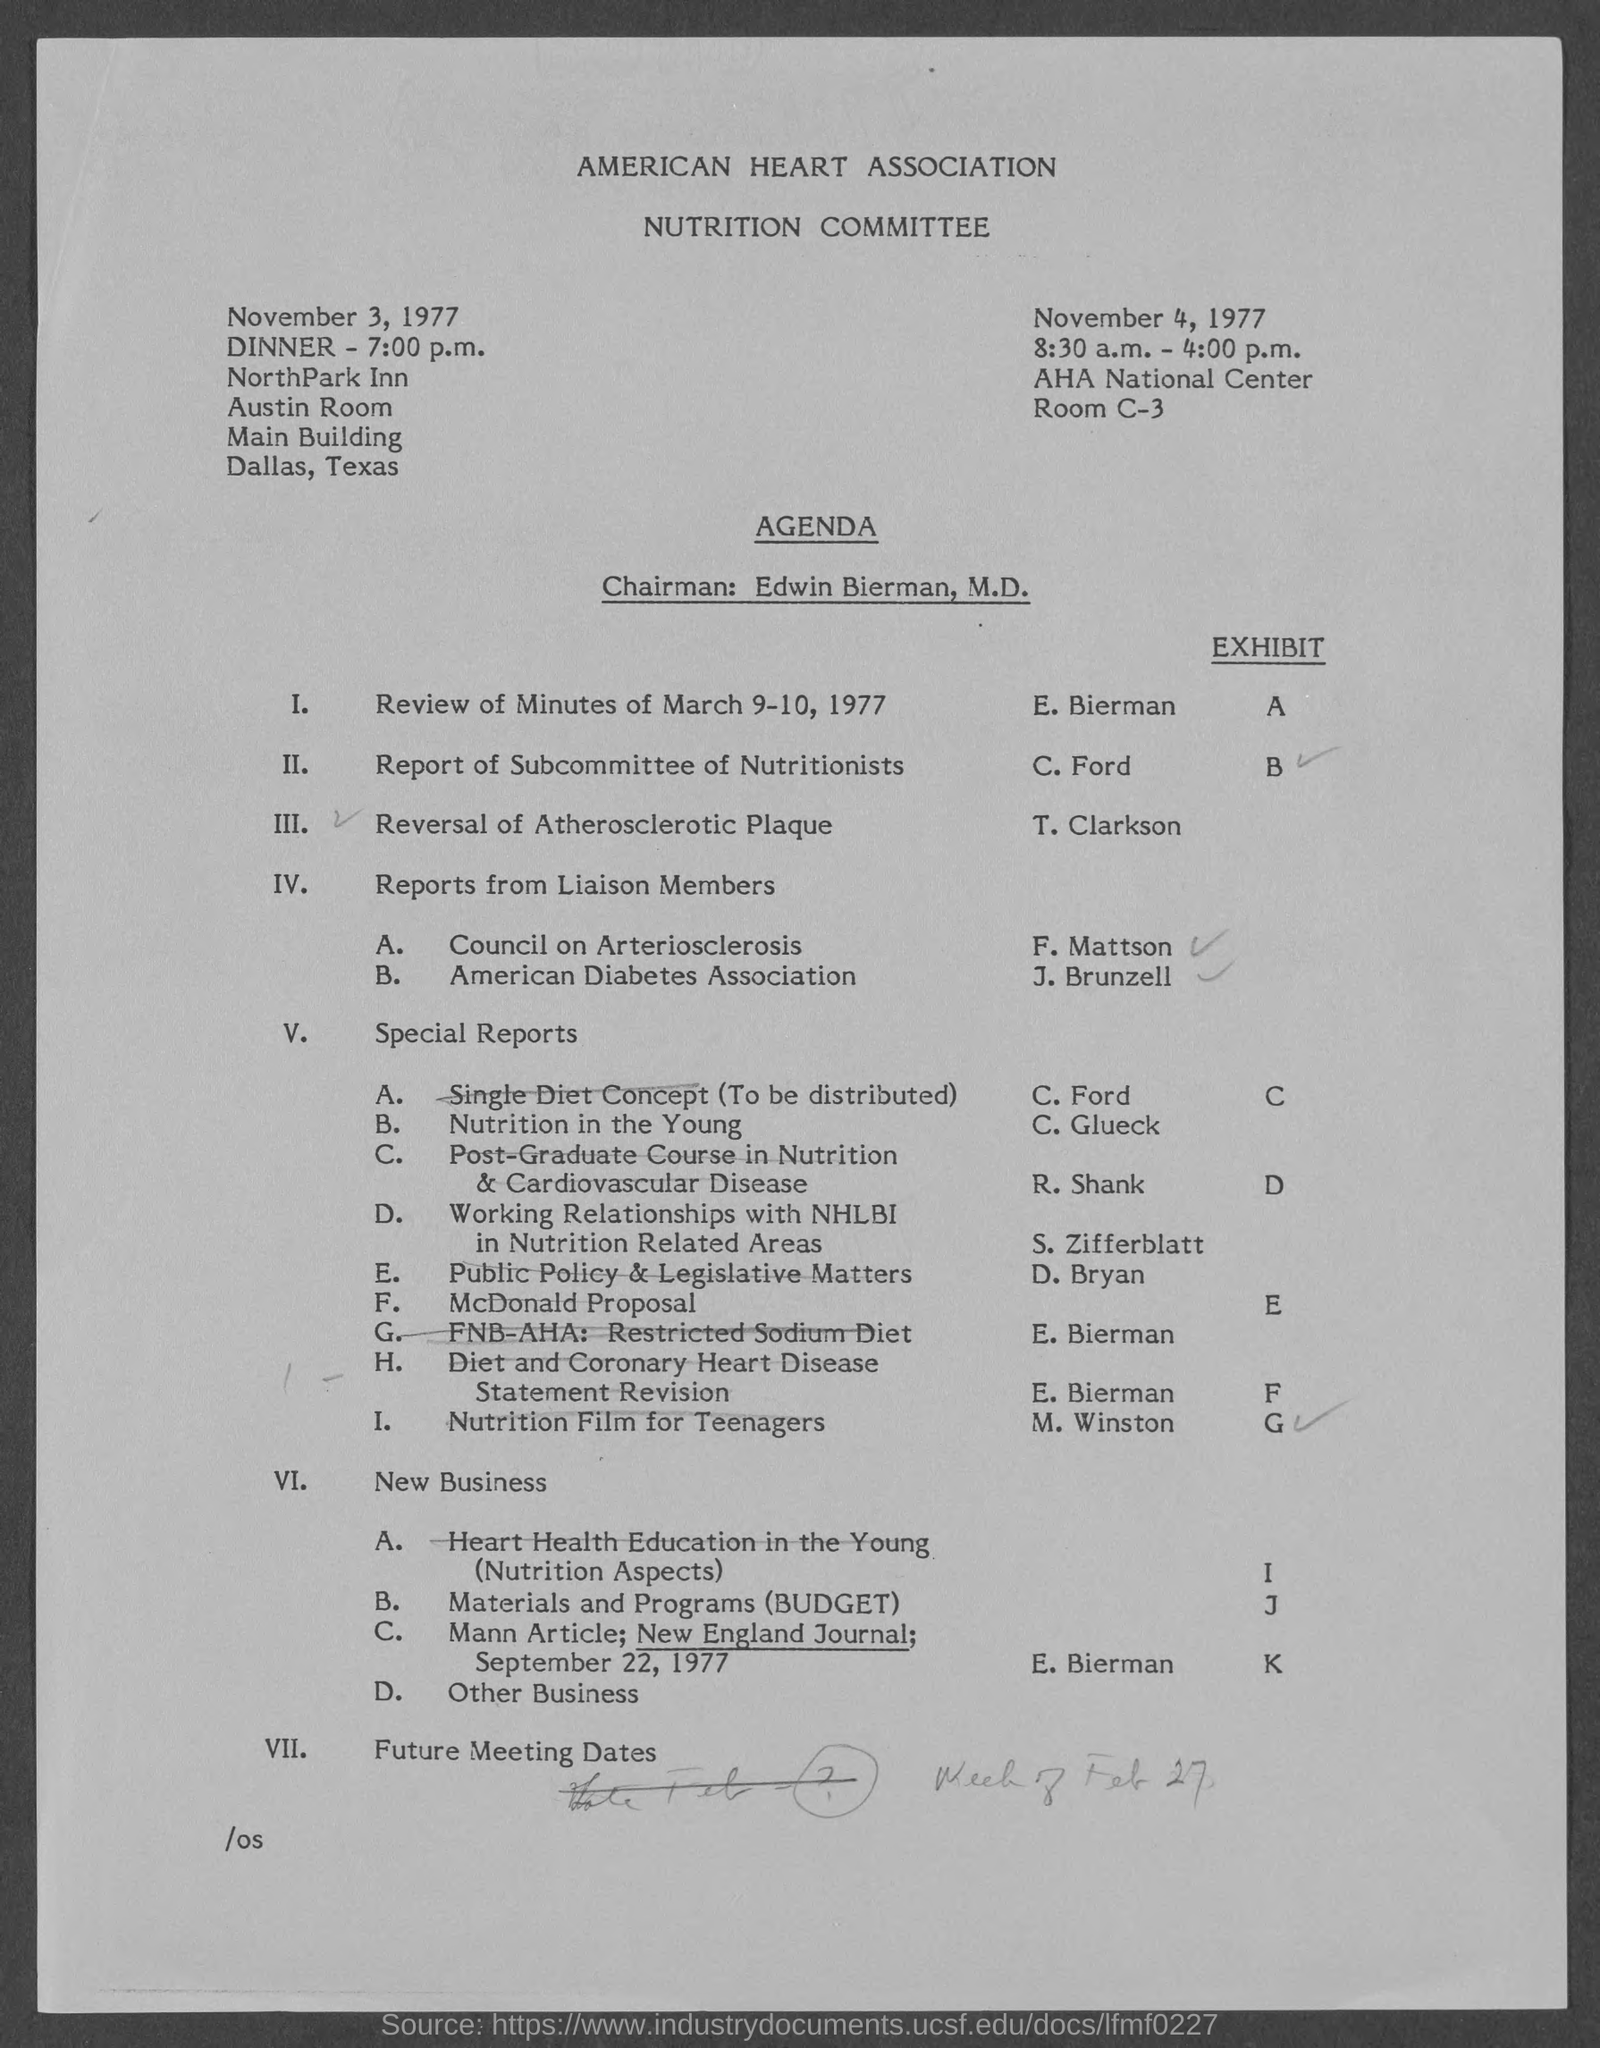Identify some key points in this picture. The dinner is being held at the NorthPark Inn. Edwin Bierman, M.D., is the Chairman. The meeting was held on November 4, 1977, at the AHA National Center in Room C-3. 